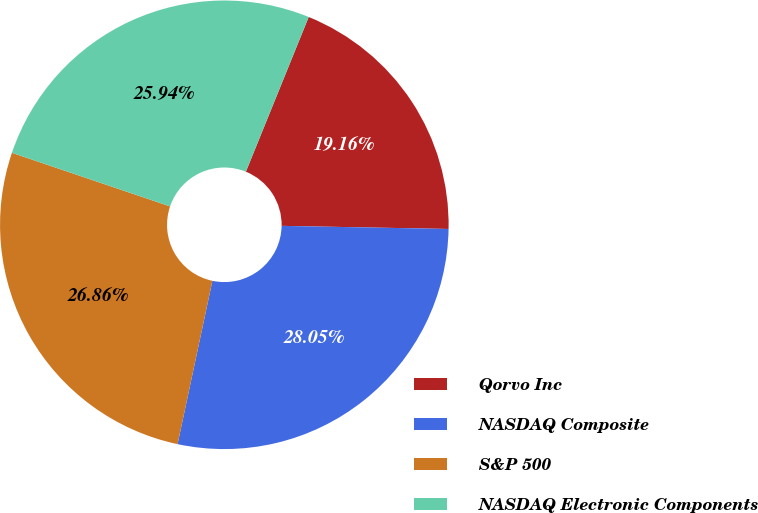Convert chart to OTSL. <chart><loc_0><loc_0><loc_500><loc_500><pie_chart><fcel>Qorvo Inc<fcel>NASDAQ Composite<fcel>S&P 500<fcel>NASDAQ Electronic Components<nl><fcel>19.16%<fcel>28.05%<fcel>26.86%<fcel>25.94%<nl></chart> 